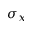Convert formula to latex. <formula><loc_0><loc_0><loc_500><loc_500>\sigma _ { x }</formula> 